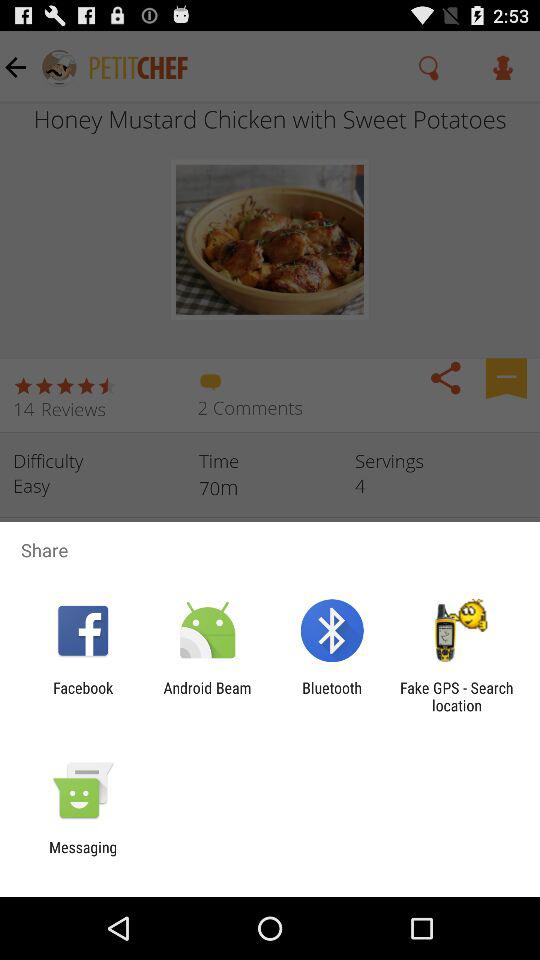Through which applications can we share? You can share with "Facebook", "Android Beam", "Bluetooth", "Fake GPS - Search location" and "Messaging". 